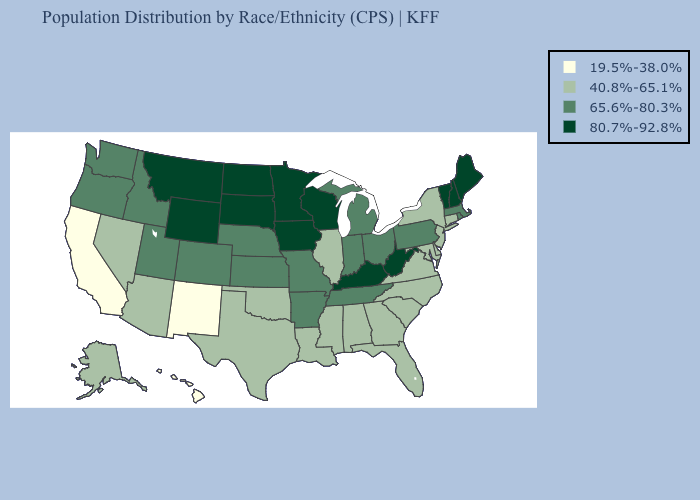What is the value of Missouri?
Short answer required. 65.6%-80.3%. Does Montana have the highest value in the USA?
Concise answer only. Yes. Does Illinois have the same value as Louisiana?
Give a very brief answer. Yes. Does Mississippi have a higher value than Hawaii?
Short answer required. Yes. What is the lowest value in the USA?
Write a very short answer. 19.5%-38.0%. Name the states that have a value in the range 65.6%-80.3%?
Answer briefly. Arkansas, Colorado, Idaho, Indiana, Kansas, Massachusetts, Michigan, Missouri, Nebraska, Ohio, Oregon, Pennsylvania, Rhode Island, Tennessee, Utah, Washington. What is the value of Virginia?
Keep it brief. 40.8%-65.1%. Does the map have missing data?
Give a very brief answer. No. What is the value of Minnesota?
Answer briefly. 80.7%-92.8%. What is the value of Colorado?
Write a very short answer. 65.6%-80.3%. What is the value of Minnesota?
Answer briefly. 80.7%-92.8%. Name the states that have a value in the range 19.5%-38.0%?
Short answer required. California, Hawaii, New Mexico. What is the highest value in the Northeast ?
Give a very brief answer. 80.7%-92.8%. Which states have the lowest value in the USA?
Answer briefly. California, Hawaii, New Mexico. Which states hav the highest value in the Northeast?
Be succinct. Maine, New Hampshire, Vermont. 